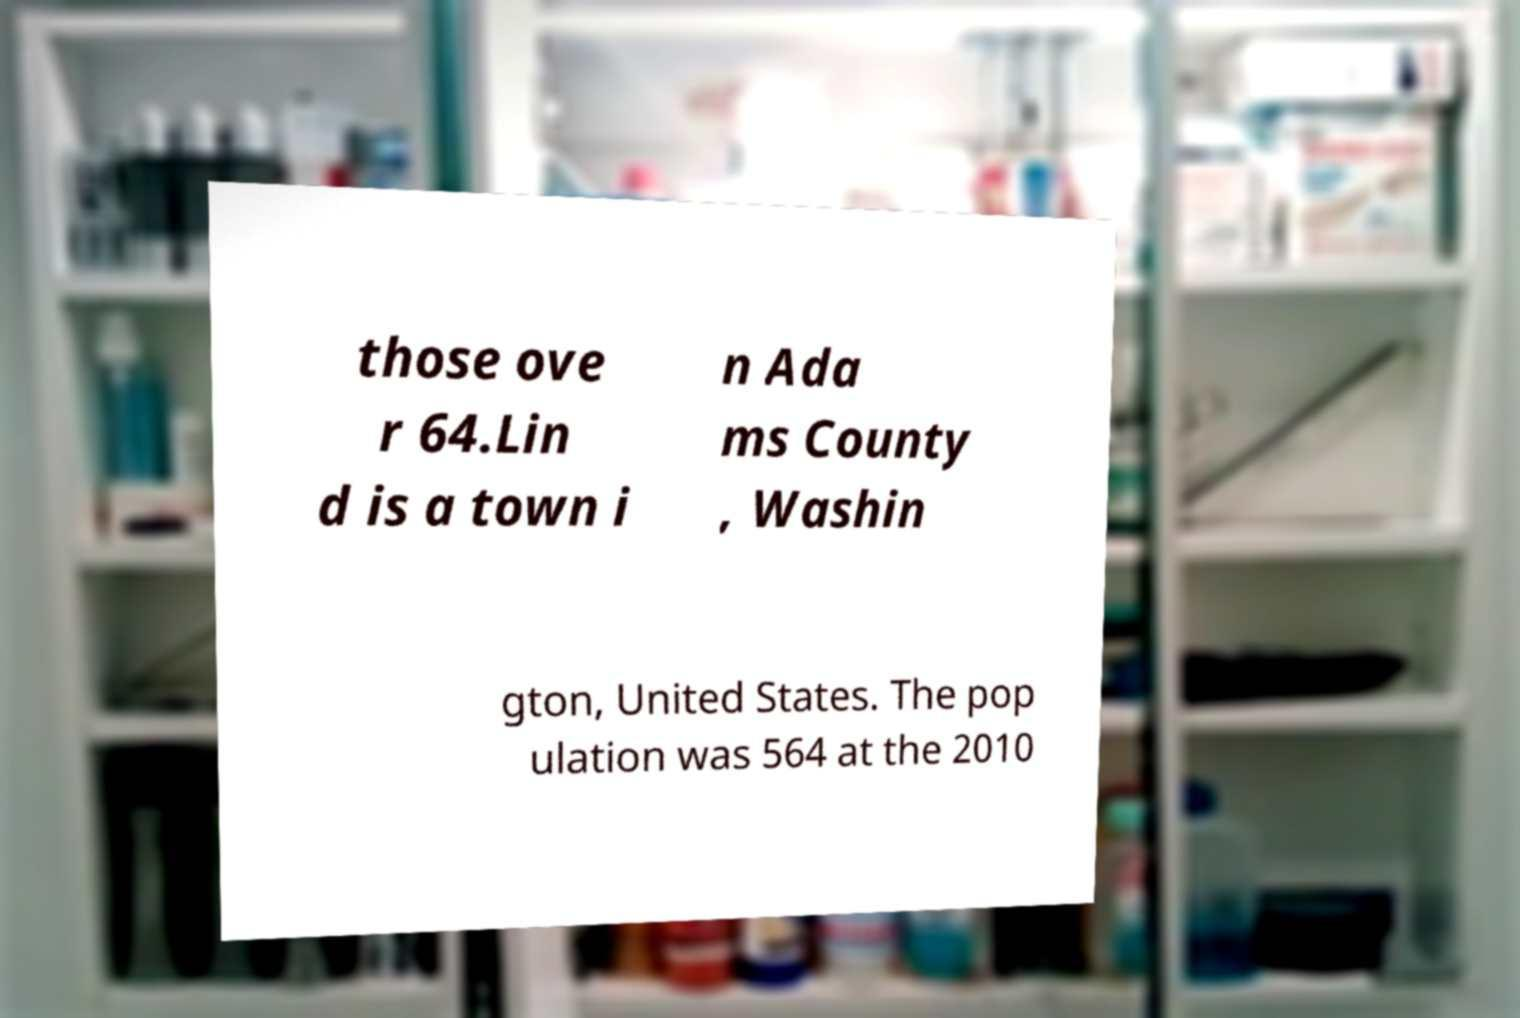What messages or text are displayed in this image? I need them in a readable, typed format. those ove r 64.Lin d is a town i n Ada ms County , Washin gton, United States. The pop ulation was 564 at the 2010 